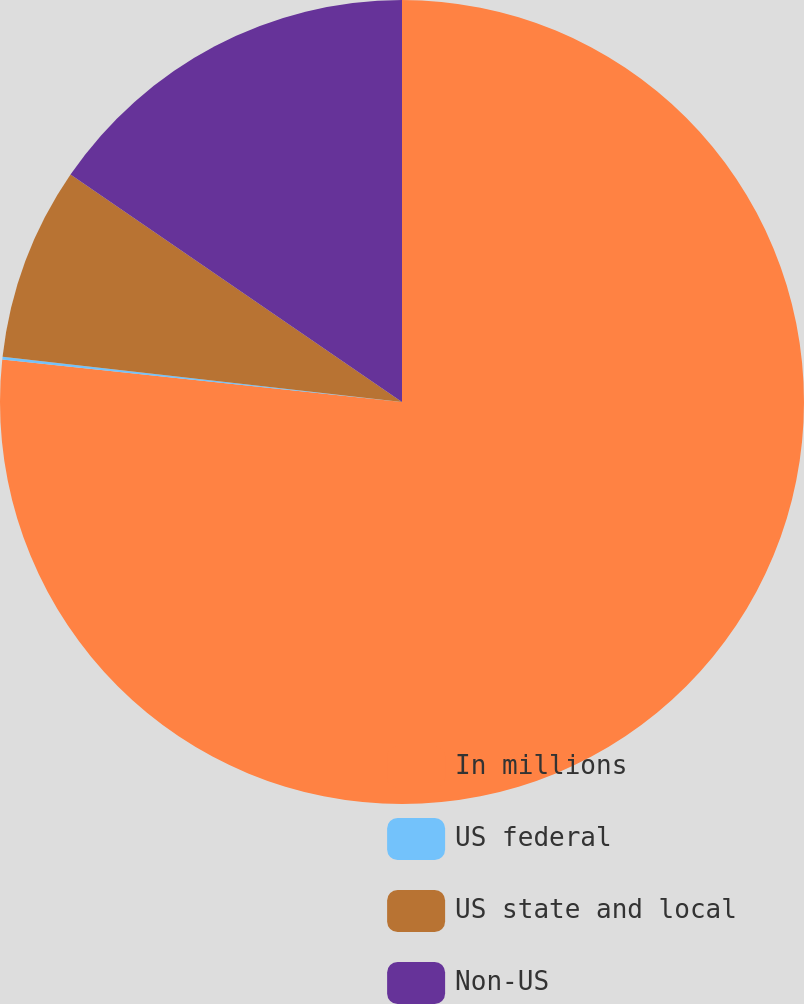Convert chart to OTSL. <chart><loc_0><loc_0><loc_500><loc_500><pie_chart><fcel>In millions<fcel>US federal<fcel>US state and local<fcel>Non-US<nl><fcel>76.69%<fcel>0.11%<fcel>7.77%<fcel>15.43%<nl></chart> 